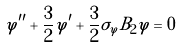<formula> <loc_0><loc_0><loc_500><loc_500>\varphi ^ { \prime \prime } + \frac { 3 } { 2 } \varphi ^ { \prime } + \frac { 3 } { 2 } \sigma _ { \varphi } B _ { 2 } \varphi = 0</formula> 